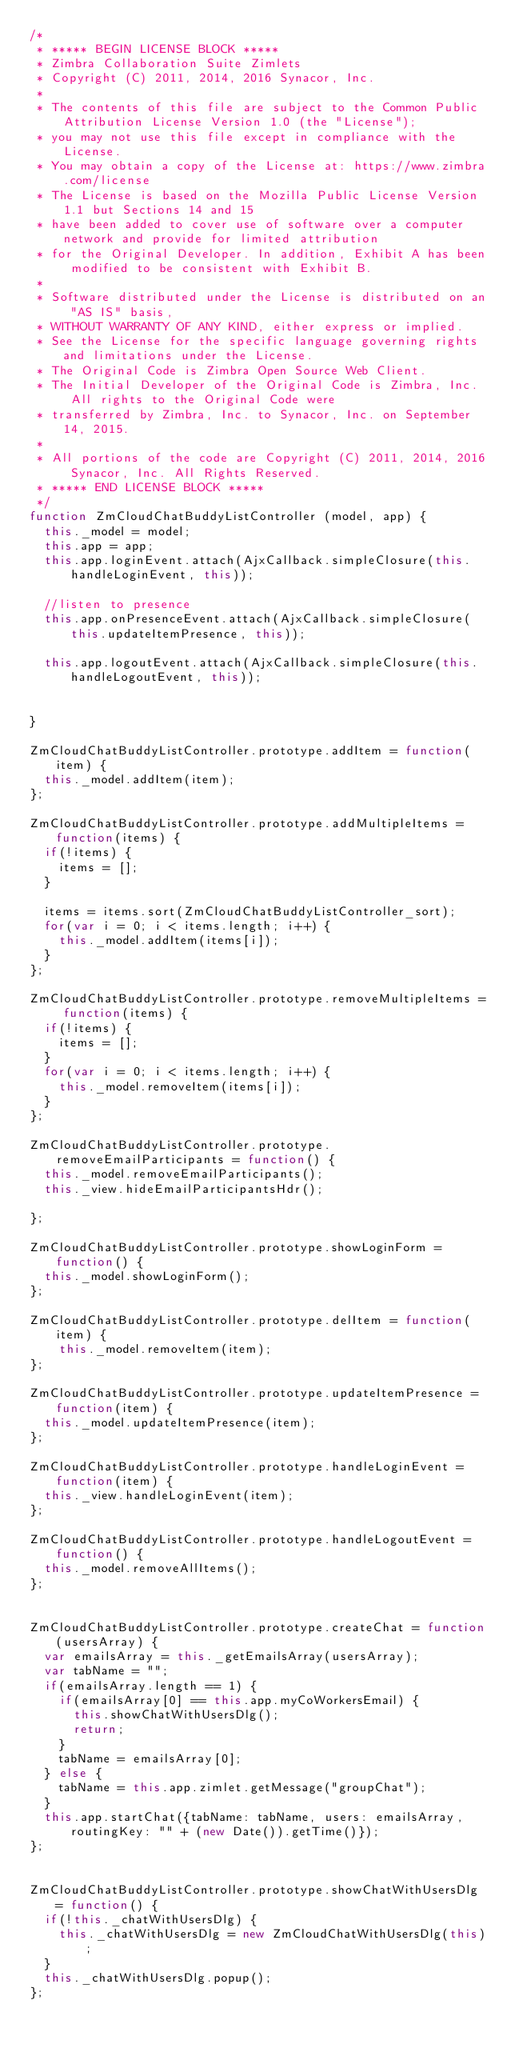Convert code to text. <code><loc_0><loc_0><loc_500><loc_500><_JavaScript_>/*
 * ***** BEGIN LICENSE BLOCK *****
 * Zimbra Collaboration Suite Zimlets
 * Copyright (C) 2011, 2014, 2016 Synacor, Inc.
 *
 * The contents of this file are subject to the Common Public Attribution License Version 1.0 (the "License");
 * you may not use this file except in compliance with the License.
 * You may obtain a copy of the License at: https://www.zimbra.com/license
 * The License is based on the Mozilla Public License Version 1.1 but Sections 14 and 15
 * have been added to cover use of software over a computer network and provide for limited attribution
 * for the Original Developer. In addition, Exhibit A has been modified to be consistent with Exhibit B.
 *
 * Software distributed under the License is distributed on an "AS IS" basis,
 * WITHOUT WARRANTY OF ANY KIND, either express or implied.
 * See the License for the specific language governing rights and limitations under the License.
 * The Original Code is Zimbra Open Source Web Client.
 * The Initial Developer of the Original Code is Zimbra, Inc.  All rights to the Original Code were
 * transferred by Zimbra, Inc. to Synacor, Inc. on September 14, 2015.
 *
 * All portions of the code are Copyright (C) 2011, 2014, 2016 Synacor, Inc. All Rights Reserved.
 * ***** END LICENSE BLOCK *****
 */
function ZmCloudChatBuddyListController (model, app) {
	this._model = model;
	this.app = app;
	this.app.loginEvent.attach(AjxCallback.simpleClosure(this.handleLoginEvent, this));

	//listen to presence
	this.app.onPresenceEvent.attach(AjxCallback.simpleClosure(this.updateItemPresence, this));

	this.app.logoutEvent.attach(AjxCallback.simpleClosure(this.handleLogoutEvent, this));


}

ZmCloudChatBuddyListController.prototype.addItem = function(item) {
	this._model.addItem(item);
};

ZmCloudChatBuddyListController.prototype.addMultipleItems = function(items) {
	if(!items) {
		items = [];
	}

	items = items.sort(ZmCloudChatBuddyListController_sort);
	for(var i = 0; i < items.length; i++) {
		this._model.addItem(items[i]);
	}
};

ZmCloudChatBuddyListController.prototype.removeMultipleItems = function(items) {
	if(!items) {
		items = [];
	}
	for(var i = 0; i < items.length; i++) {
		this._model.removeItem(items[i]);
	}
};

ZmCloudChatBuddyListController.prototype.removeEmailParticipants = function() {
	this._model.removeEmailParticipants();
	this._view.hideEmailParticipantsHdr();

};

ZmCloudChatBuddyListController.prototype.showLoginForm = function() {
	this._model.showLoginForm();
};

ZmCloudChatBuddyListController.prototype.delItem = function(item) {
		this._model.removeItem(item);
};

ZmCloudChatBuddyListController.prototype.updateItemPresence = function(item) {
	this._model.updateItemPresence(item);
};

ZmCloudChatBuddyListController.prototype.handleLoginEvent = function(item) {
	this._view.handleLoginEvent(item);
};

ZmCloudChatBuddyListController.prototype.handleLogoutEvent = function() {
	this._model.removeAllItems();
};


ZmCloudChatBuddyListController.prototype.createChat = function(usersArray) {
	var emailsArray = this._getEmailsArray(usersArray);
	var tabName = "";
	if(emailsArray.length == 1) {
		if(emailsArray[0] == this.app.myCoWorkersEmail) {
			this.showChatWithUsersDlg();
			return;
		}
		tabName = emailsArray[0];
	} else {
		tabName = this.app.zimlet.getMessage("groupChat");
	}
	this.app.startChat({tabName: tabName, users: emailsArray, routingKey: "" + (new Date()).getTime()});
};


ZmCloudChatBuddyListController.prototype.showChatWithUsersDlg = function() {
	if(!this._chatWithUsersDlg) {
		this._chatWithUsersDlg = new ZmCloudChatWithUsersDlg(this);
	}
	this._chatWithUsersDlg.popup();
};
</code> 